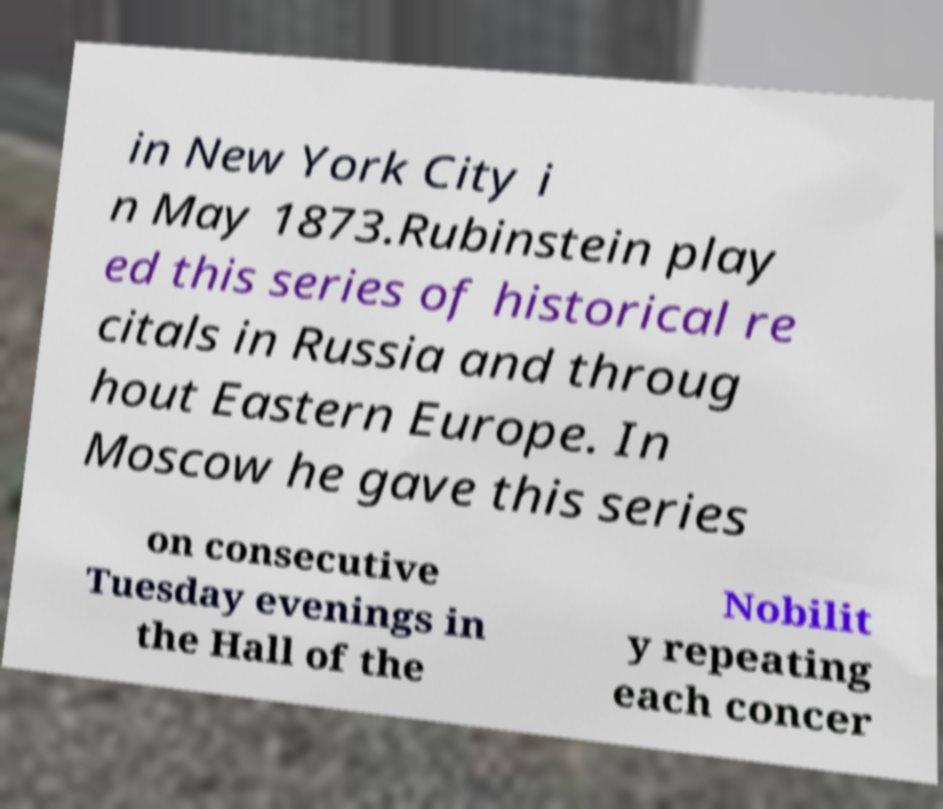Can you accurately transcribe the text from the provided image for me? in New York City i n May 1873.Rubinstein play ed this series of historical re citals in Russia and throug hout Eastern Europe. In Moscow he gave this series on consecutive Tuesday evenings in the Hall of the Nobilit y repeating each concer 